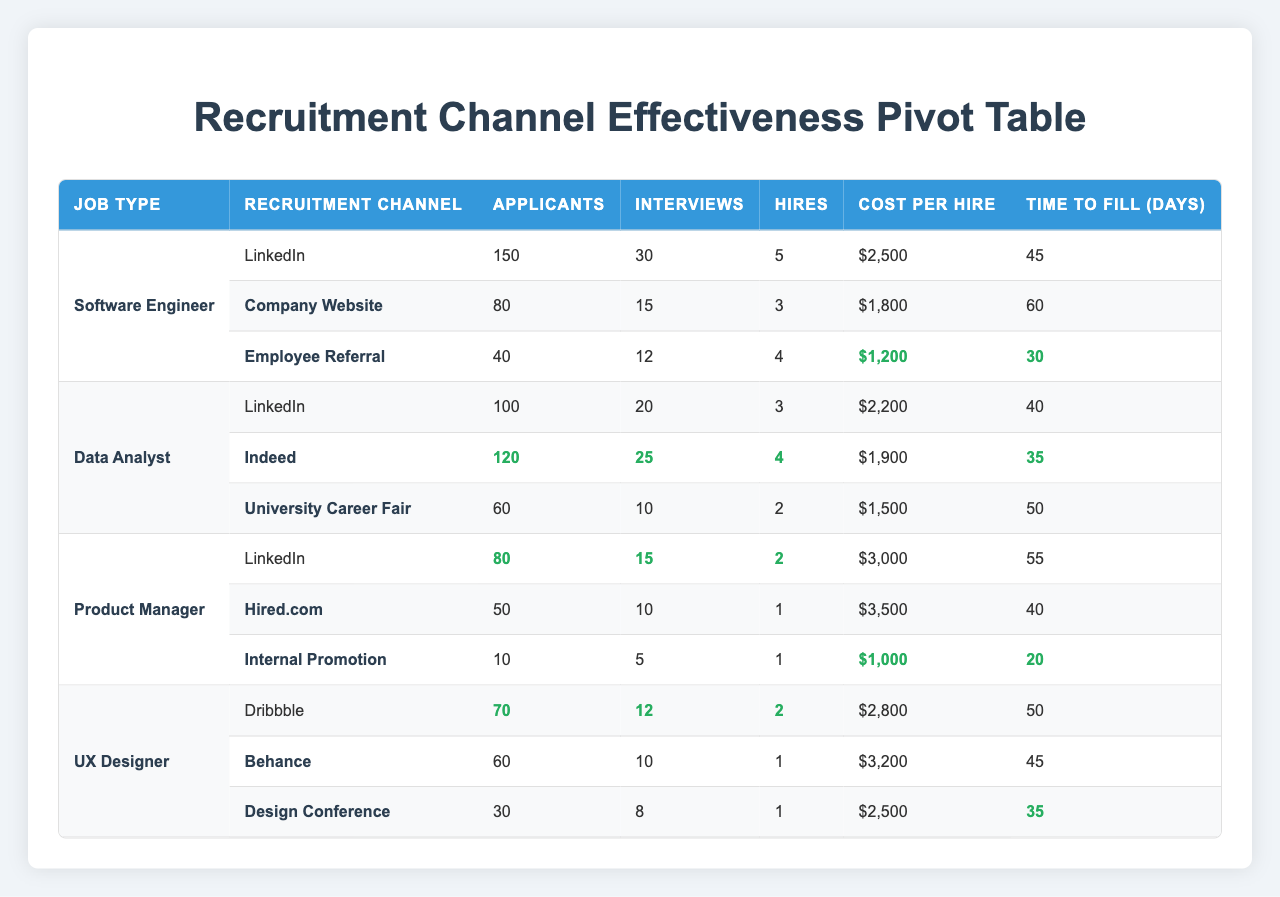What is the total number of applicants for the Software Engineer position? The Software Engineer position has three recruitment channels: LinkedIn (150 applicants), Company Website (80 applicants), and Employee Referral (40 applicants). Adding these together gives 150 + 80 + 40 = 270.
Answer: 270 Which recruitment channel for the Data Analyst position resulted in the lowest cost per hire? The recruitment channels for Data Analyst are LinkedIn ($2200), Indeed ($1900), and University Career Fair ($1500). The lowest cost per hire is $1500 from University Career Fair.
Answer: $1500 Is the average time to fill for Product Manager positions greater than 50 days? The time to fill for Product Manager from LinkedIn is 55 days, Hired.com is 40 days, and Internal Promotion is 20 days. The average is (55 + 40 + 20) / 3 = 115/3 = 38.33, which is not greater than 50 days.
Answer: No How many hires were made through the Employee Referral channel for Software Engineers? According to the table, the Employee Referral channel produced 4 hires for Software Engineers, which is directly listed.
Answer: 4 What is the total number of interviews conducted across all recruitment channels for the UX Designer position? The interviews for UX Designer are 12 from Dribbble, 10 from Behance, and 8 from Design Conference. Totaling them gives 12 + 10 + 8 = 30 interviews.
Answer: 30 Which recruitment channel for the Product Manager position had the highest number of hires? The Product Manager channels had LinkedIn (2 hires), Hired.com (1 hire), and Internal Promotion (1 hire). Thus, LinkedIn leads with the highest hires of 2.
Answer: 2 Is the average number of applicants for all Data Analyst recruitment channels greater than 80? The applicants for the Data Analyst channels are 100 (LinkedIn), 120 (Indeed), and 60 (University Career Fair). The average is (100 + 120 + 60) / 3 = 280 / 3 ≈ 93.33, which is greater than 80.
Answer: Yes What is the highest cost per hire among all the recruitment channels? The costs per hire for the recruitment channels are: Software Engineer - Employee Referral ($1200), Data Analyst - University Career Fair ($1500), Product Manager - Hired.com ($3500), and UX Designer - Behance ($3200). The highest cost per hire is $3500 from Hired.com.
Answer: $3500 What is the difference in the number of hires between the channels with the most and the least hires for UX Designer? In UX Designer, Dribbble had 2 hires, while Behance and Design Conference had 1 hire each. The difference is 2 - 1 = 1.
Answer: 1 